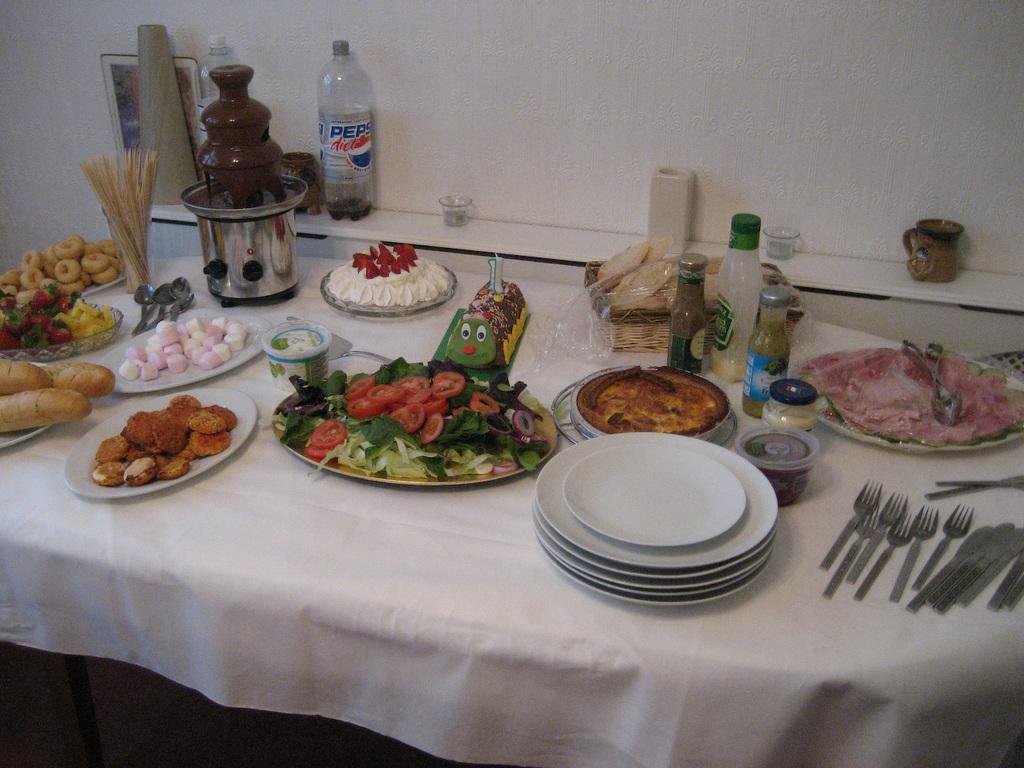What is on the plates that are visible in the image? There are plates with food in the image. What utensils are present in the image? There are forks and knives in the image. What type of containers are visible in the image? There are bottles and cans in the image. Where are all of these objects located? All of these objects are on a table. Can you see a yoke in the image? No, there is no yoke present in the image. What type of boundary is visible in the image? There is no boundary visible in the image; it is a still life of objects on a table. 